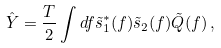<formula> <loc_0><loc_0><loc_500><loc_500>\hat { Y } = \frac { T } { 2 } \int d f \tilde { s } ^ { * } _ { 1 } ( f ) \tilde { s } _ { 2 } ( f ) \tilde { Q } ( f ) \, ,</formula> 